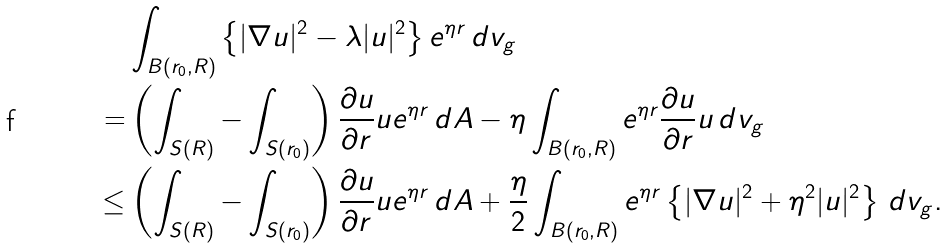Convert formula to latex. <formula><loc_0><loc_0><loc_500><loc_500>& \int _ { B ( r _ { 0 } , R ) } \left \{ | \nabla u | ^ { 2 } - \lambda | u | ^ { 2 } \right \} e ^ { \eta r } \, d v _ { g } \\ = & \left ( \int _ { S ( R ) } - \int _ { S ( r _ { 0 } ) } \right ) \frac { \partial u } { \partial r } u e ^ { \eta r } \, d A - \eta \int _ { B ( r _ { 0 } , R ) } e ^ { \eta r } \frac { \partial u } { \partial r } u \, d v _ { g } \\ \leq & \left ( \int _ { S ( R ) } - \int _ { S ( r _ { 0 } ) } \right ) \frac { \partial u } { \partial r } u e ^ { \eta r } \, d A + \frac { \eta } { 2 } \int _ { B ( r _ { 0 } , R ) } e ^ { \eta r } \left \{ | \nabla u | ^ { 2 } + \eta ^ { 2 } | u | ^ { 2 } \right \} \, d v _ { g } .</formula> 